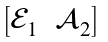Convert formula to latex. <formula><loc_0><loc_0><loc_500><loc_500>\begin{bmatrix} \mathcal { E } _ { 1 } & \mathcal { A } _ { 2 } \end{bmatrix}</formula> 